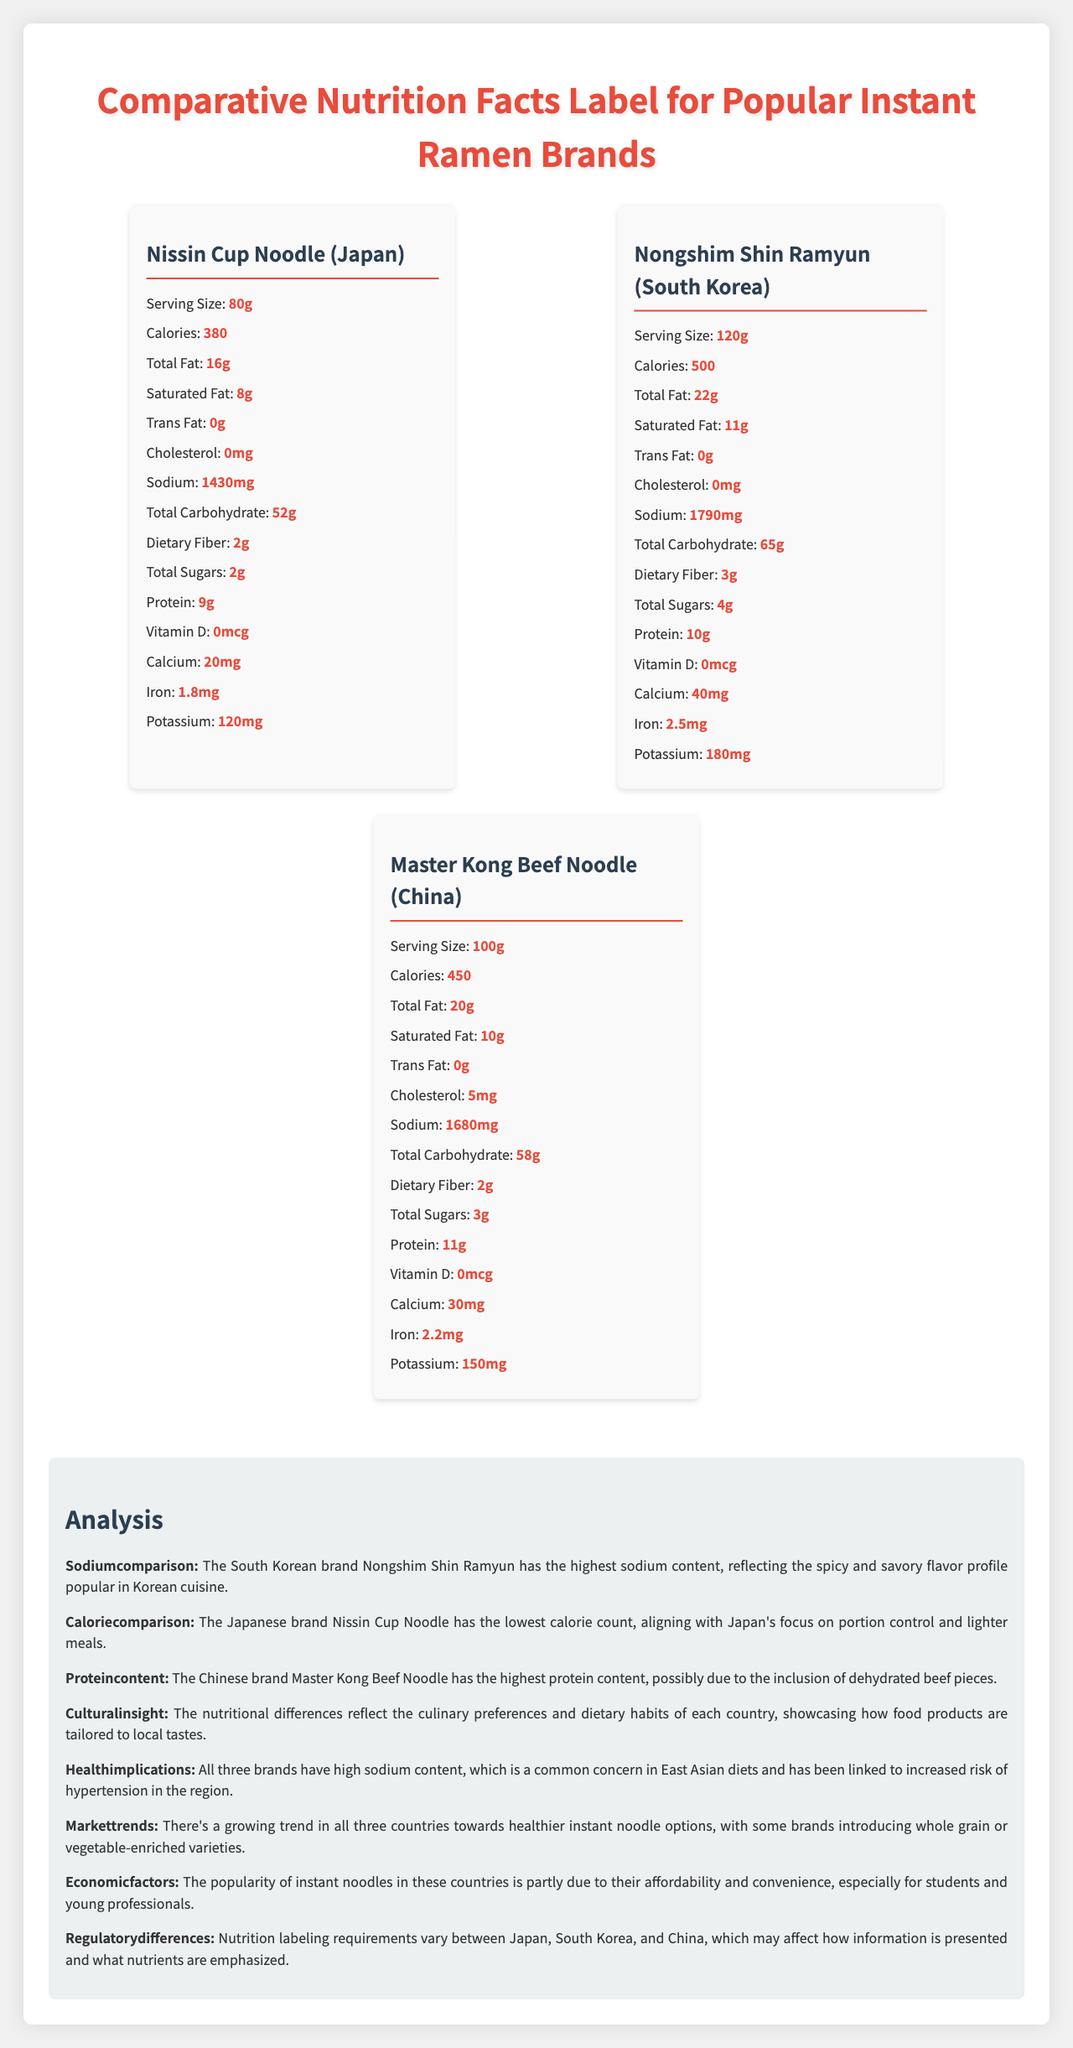what is the serving size of Nissin Cup Noodle? The serving size is listed under the brand name Nissin Cup Noodle in the document.
Answer: 80g which brand has the highest sodium content? The sodium content for each brand is listed, and Nongshim Shin Ramyun has 1790mg, the highest among the three brands.
Answer: Nongshim Shin Ramyun What is the total fat content of Master Kong Beef Noodle? The total fat content for Master Kong Beef Noodle is listed as 20g.
Answer: 20g which brand has the highest protein content? Master Kong Beef Noodle has 11g of protein, which is higher than the other two brands.
Answer: Master Kong Beef Noodle what is the calorie count for Nissin Cup Noodle? The calorie count for Nissin Cup Noodle is listed as 380.
Answer: 380 In which country is the brand Nongshim Shin Ramyun made? The document lists that Nongshim Shin Ramyun is from South Korea.
Answer: South Korea Do all brands have trans fat? The trans fat content is listed as 0g for all three brands.
Answer: No Summarize the key findings about the nutritional differences among the instant ramen brands from Japan, South Korea, and China. The document lists the nutritional data for various brands and provides an analysis section that outlines the key differences and insights about how these relate to culinary and cultural preferences.
Answer: The document compares the nutritional facts of popular instant ramen brands from Japan, South Korea, and China. Nissin Cup Noodle from Japan has the lowest calorie count and a focus on portion control. Nongshim Shin Ramyun from South Korea has the highest sodium content, reflecting the country's culinary preferences for savory flavors. Master Kong Beef Noodle from China has the highest protein content due to possible inclusion of dehydrated beef. Overall, all brands have high sodium content, which is a common dietary concern in East Asia. What is the vitamin D content of all the brands? The vitamin D content for all the brands (Nissin Cup Noodle, Nongshim Shin Ramyun, Master Kong Beef Noodle) is listed as 0mcg.
Answer: 0mcg Which brand has the lowest calcium content? A. Nissin Cup Noodle B. Nongshim Shin Ramyun C. Master Kong Beef Noodle D. All have equal content Nissin Cup Noodle has 20mg of calcium, which is lower than the 40mg in Nongshim Shin Ramyun and 30mg in Master Kong Beef Noodle.
Answer: A What factors could lead to the differences in sodium content across the brands? The document does not provide specific reasons behind the differences in sodium content, only listing the values and providing a general cultural insight.
Answer: Not enough information 